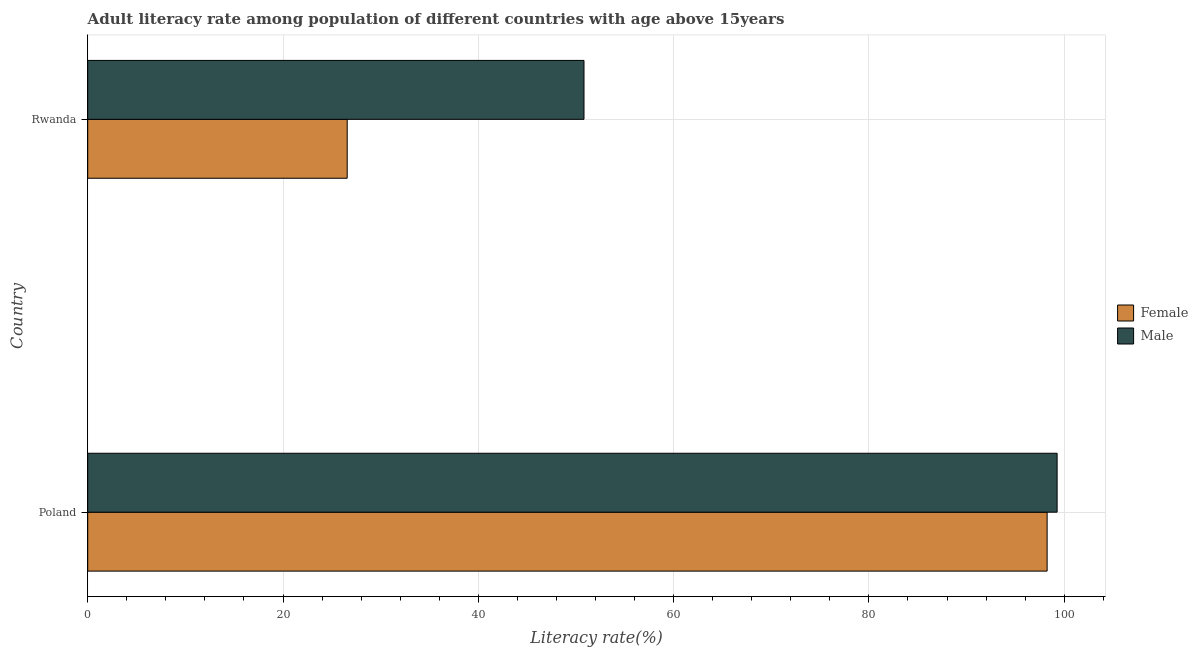Are the number of bars on each tick of the Y-axis equal?
Provide a short and direct response. Yes. What is the label of the 1st group of bars from the top?
Provide a short and direct response. Rwanda. In how many cases, is the number of bars for a given country not equal to the number of legend labels?
Your answer should be very brief. 0. What is the female adult literacy rate in Poland?
Your answer should be compact. 98.25. Across all countries, what is the maximum male adult literacy rate?
Your answer should be very brief. 99.28. Across all countries, what is the minimum male adult literacy rate?
Your answer should be compact. 50.82. In which country was the male adult literacy rate minimum?
Provide a short and direct response. Rwanda. What is the total male adult literacy rate in the graph?
Offer a terse response. 150.1. What is the difference between the female adult literacy rate in Poland and that in Rwanda?
Make the answer very short. 71.68. What is the difference between the male adult literacy rate in Poland and the female adult literacy rate in Rwanda?
Offer a terse response. 72.7. What is the average male adult literacy rate per country?
Offer a very short reply. 75.05. What is the difference between the female adult literacy rate and male adult literacy rate in Poland?
Ensure brevity in your answer.  -1.02. What is the ratio of the male adult literacy rate in Poland to that in Rwanda?
Your answer should be compact. 1.95. Is the male adult literacy rate in Poland less than that in Rwanda?
Your response must be concise. No. In how many countries, is the male adult literacy rate greater than the average male adult literacy rate taken over all countries?
Your answer should be compact. 1. How many bars are there?
Provide a succinct answer. 4. Are all the bars in the graph horizontal?
Ensure brevity in your answer.  Yes. Are the values on the major ticks of X-axis written in scientific E-notation?
Offer a terse response. No. Does the graph contain grids?
Make the answer very short. Yes. Where does the legend appear in the graph?
Offer a very short reply. Center right. How are the legend labels stacked?
Your response must be concise. Vertical. What is the title of the graph?
Your response must be concise. Adult literacy rate among population of different countries with age above 15years. What is the label or title of the X-axis?
Provide a short and direct response. Literacy rate(%). What is the Literacy rate(%) of Female in Poland?
Offer a terse response. 98.25. What is the Literacy rate(%) of Male in Poland?
Your answer should be compact. 99.28. What is the Literacy rate(%) of Female in Rwanda?
Offer a terse response. 26.57. What is the Literacy rate(%) of Male in Rwanda?
Provide a succinct answer. 50.82. Across all countries, what is the maximum Literacy rate(%) in Female?
Give a very brief answer. 98.25. Across all countries, what is the maximum Literacy rate(%) in Male?
Keep it short and to the point. 99.28. Across all countries, what is the minimum Literacy rate(%) in Female?
Offer a very short reply. 26.57. Across all countries, what is the minimum Literacy rate(%) in Male?
Offer a terse response. 50.82. What is the total Literacy rate(%) in Female in the graph?
Make the answer very short. 124.83. What is the total Literacy rate(%) in Male in the graph?
Your response must be concise. 150.1. What is the difference between the Literacy rate(%) in Female in Poland and that in Rwanda?
Keep it short and to the point. 71.68. What is the difference between the Literacy rate(%) in Male in Poland and that in Rwanda?
Provide a succinct answer. 48.45. What is the difference between the Literacy rate(%) in Female in Poland and the Literacy rate(%) in Male in Rwanda?
Provide a succinct answer. 47.43. What is the average Literacy rate(%) in Female per country?
Offer a very short reply. 62.41. What is the average Literacy rate(%) in Male per country?
Keep it short and to the point. 75.05. What is the difference between the Literacy rate(%) of Female and Literacy rate(%) of Male in Poland?
Offer a terse response. -1.02. What is the difference between the Literacy rate(%) in Female and Literacy rate(%) in Male in Rwanda?
Ensure brevity in your answer.  -24.25. What is the ratio of the Literacy rate(%) in Female in Poland to that in Rwanda?
Your response must be concise. 3.7. What is the ratio of the Literacy rate(%) of Male in Poland to that in Rwanda?
Ensure brevity in your answer.  1.95. What is the difference between the highest and the second highest Literacy rate(%) of Female?
Make the answer very short. 71.68. What is the difference between the highest and the second highest Literacy rate(%) in Male?
Provide a succinct answer. 48.45. What is the difference between the highest and the lowest Literacy rate(%) in Female?
Your response must be concise. 71.68. What is the difference between the highest and the lowest Literacy rate(%) in Male?
Ensure brevity in your answer.  48.45. 